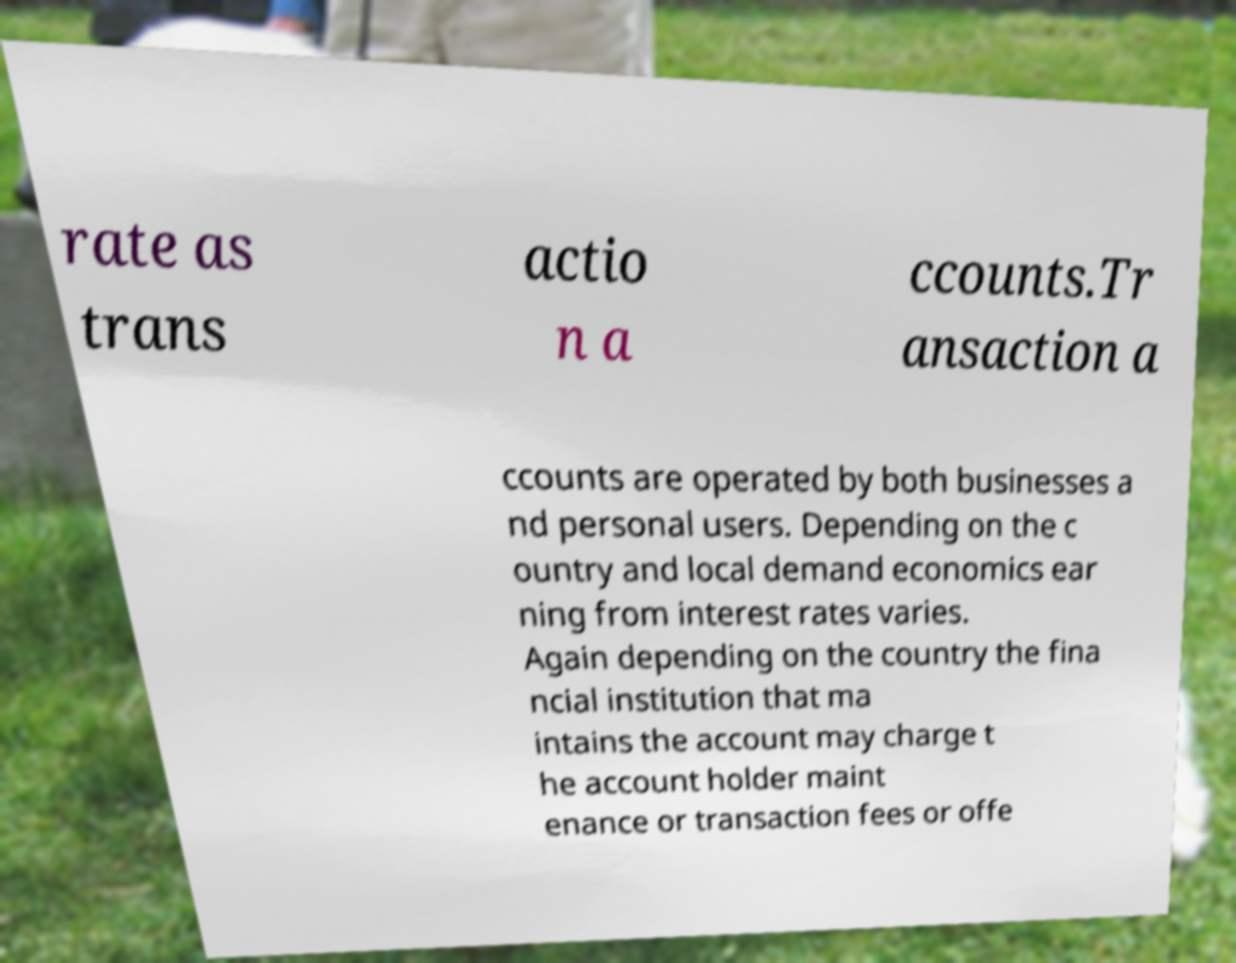What messages or text are displayed in this image? I need them in a readable, typed format. rate as trans actio n a ccounts.Tr ansaction a ccounts are operated by both businesses a nd personal users. Depending on the c ountry and local demand economics ear ning from interest rates varies. Again depending on the country the fina ncial institution that ma intains the account may charge t he account holder maint enance or transaction fees or offe 